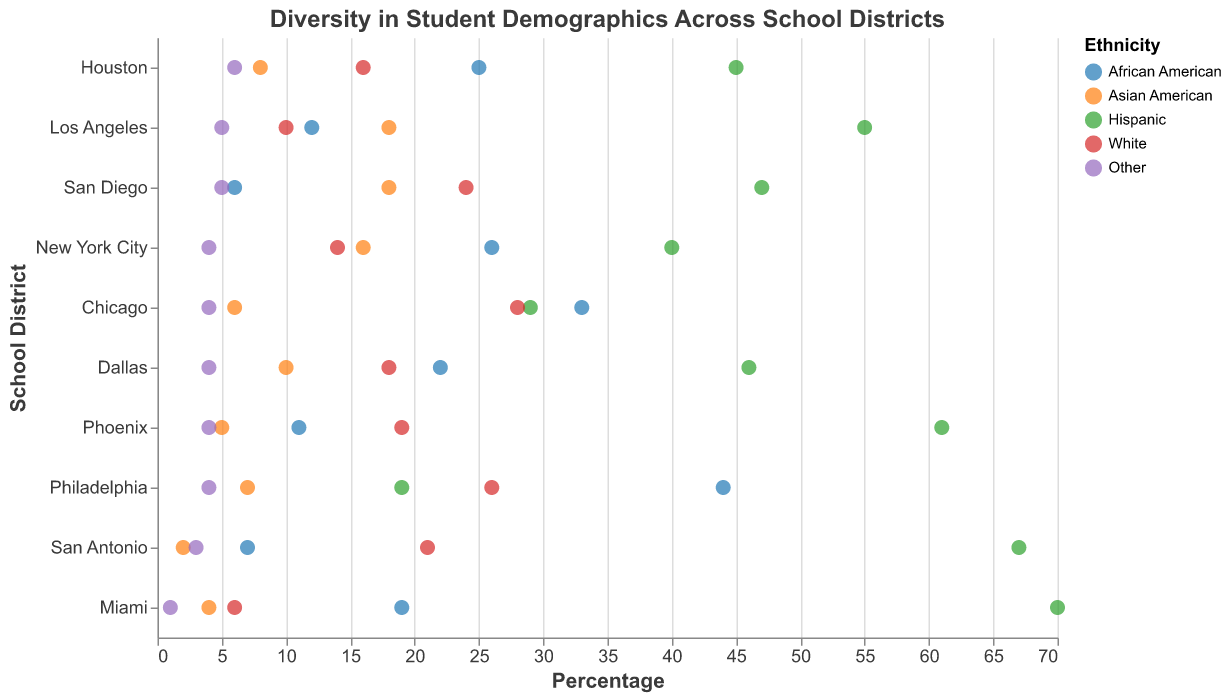How many school districts have more than 50% Hispanic students? To determine this, look at the percentage values for the Hispanic category for each school district and count the ones that are greater than 50. From the figure, Los Angeles (55%), Miami (70%), Phoenix (61%), and San Antonio (67%) all have more than 50% Hispanic students.
Answer: 4 Which school district has the highest percentage of African American students? Locate the values for the African American category for all school districts and identify the highest value. Philadelphia has the highest percentage with 44% African American students.
Answer: Philadelphia What is the range of White students' percentages across all school districts? Identify the minimum and maximum values for White students across all school districts. The minimum percentage is 6% (Miami), and the maximum is 28% (Chicago). The range is the difference between these two values: 28% - 6% = 22%.
Answer: 22% Which school district has the closest male-to-female distribution? For each school district, find the differences between the percentage values for Male and Female categories. The closest male-to-female distribution would be the smallest difference in these values. Both Houston and San Diego have a 50:50 distribution.
Answer: Houston and San Diego What is the average percentage of Low Income students across all school districts? Sum the percentage values for the Low Income category for each school district and divide by the total number of school districts (10). The total percentage is: 45 + 50 + 55 + 60 + 65 + 55 + 50 + 60 + 58 + 45 = 543. The average is 543/10 = 54.3%.
Answer: 54.3% In which school district is the 'Other' ethnicity category the smallest? Find the smallest value in the 'Other' ethnicity category across all districts. Miami has the smallest value with 1%.
Answer: Miami How many school districts have more than 30% Middle Income students? Look at the percentage values for the Middle Income category for each school district and count the ones that are greater than 30. There are New York City (40%), Miami (25%), and San Antonio (32%) having more than 30% Middle Income students.
Answer: 3 Compare the percentage of Asian American students in New York City and San Diego. Which one is greater? Check the values for Asian American students in New York City (16%) and San Diego (18%). San Diego has the greater percentage of Asian American students.
Answer: San Diego Which school district has the least diverse ethnicity distribution? The least diverse ethnicity distribution would typically have a high percentage of one ethnicity and low percentages for others. Miami has 70% Hispanic students, which makes it the least diverse in terms of ethnicity.
Answer: Miami What is the combined percentage of Hispanic and White students in Los Angeles? Add the percentages of Hispanic and White students in Los Angeles: 55% (Hispanic) + 10% (White) = 65%.
Answer: 65% 